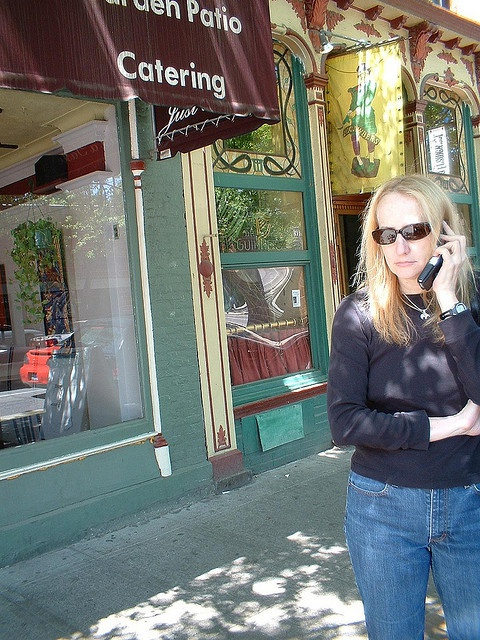Describe the objects in this image and their specific colors. I can see people in black, gray, and white tones, cell phone in black, gray, and white tones, and cell phone in black and gray tones in this image. 